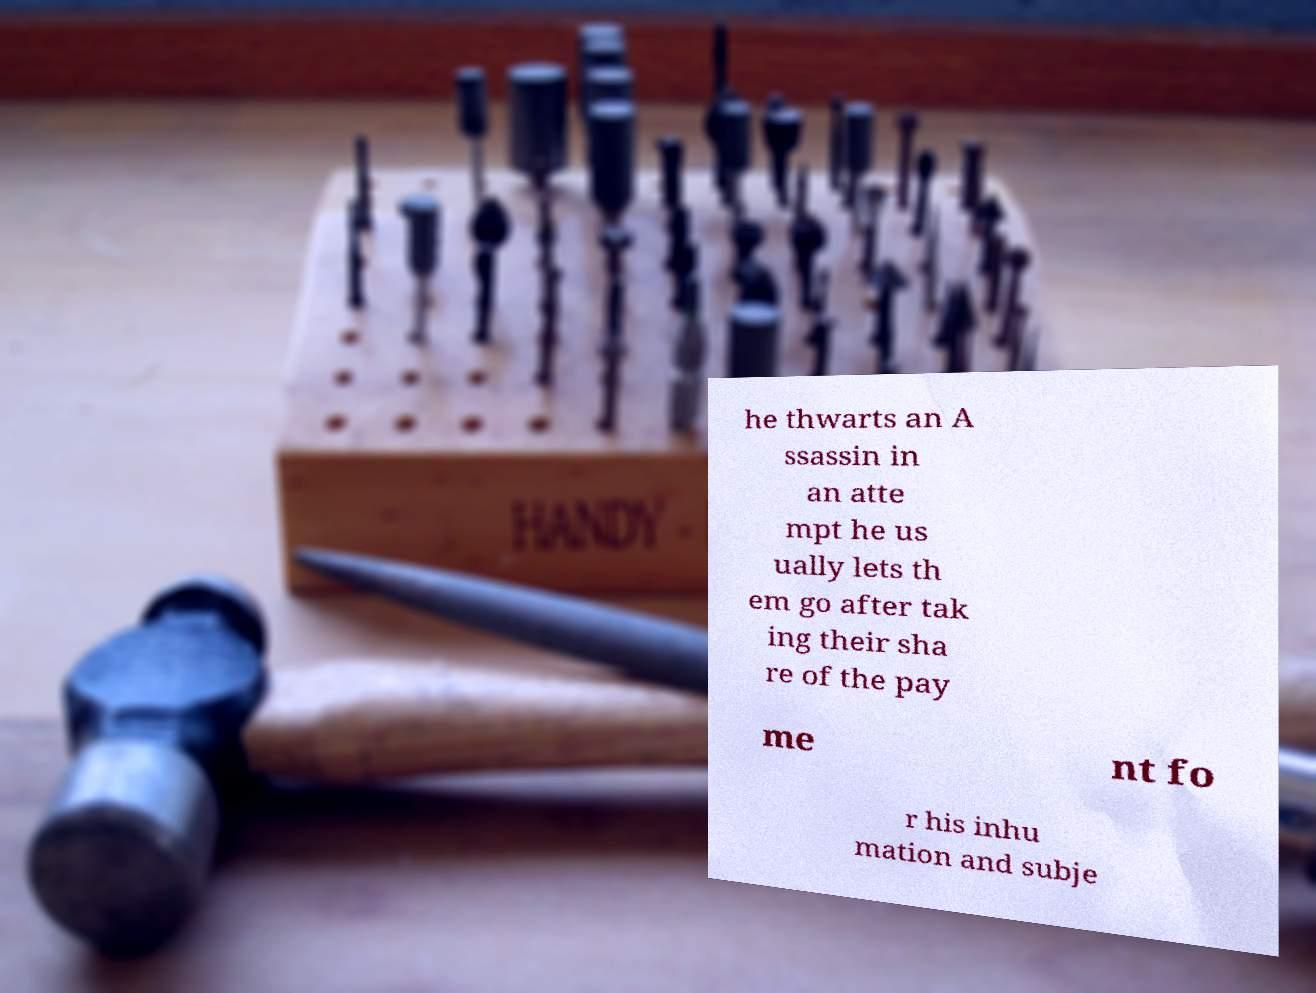Please identify and transcribe the text found in this image. he thwarts an A ssassin in an atte mpt he us ually lets th em go after tak ing their sha re of the pay me nt fo r his inhu mation and subje 